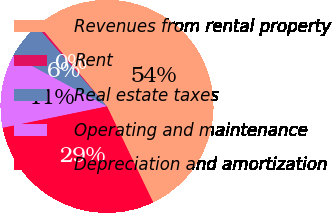Convert chart to OTSL. <chart><loc_0><loc_0><loc_500><loc_500><pie_chart><fcel>Revenues from rental property<fcel>Rent<fcel>Real estate taxes<fcel>Operating and maintenance<fcel>Depreciation and amortization<nl><fcel>53.97%<fcel>0.34%<fcel>5.71%<fcel>11.07%<fcel>28.91%<nl></chart> 